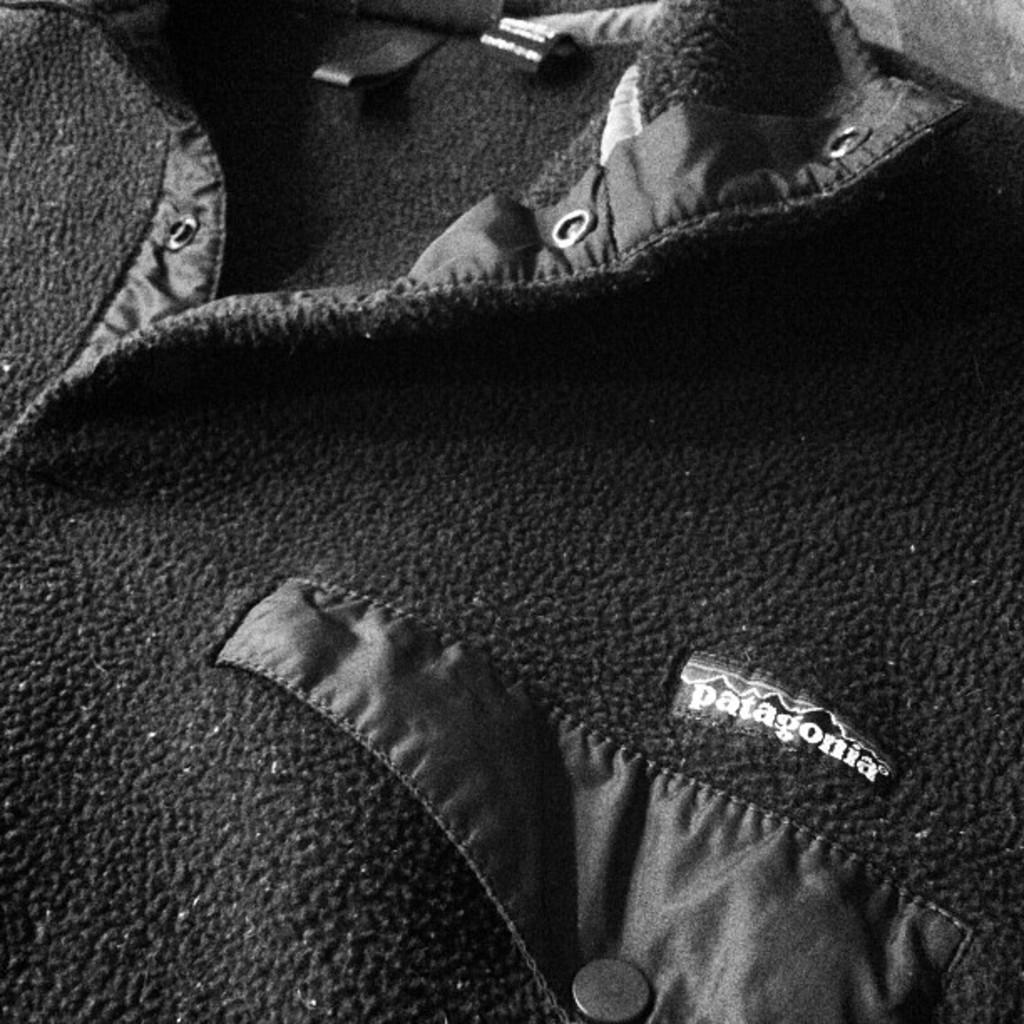In one or two sentences, can you explain what this image depicts? In this image we can see cloth. Here we can see a tag with some text. 